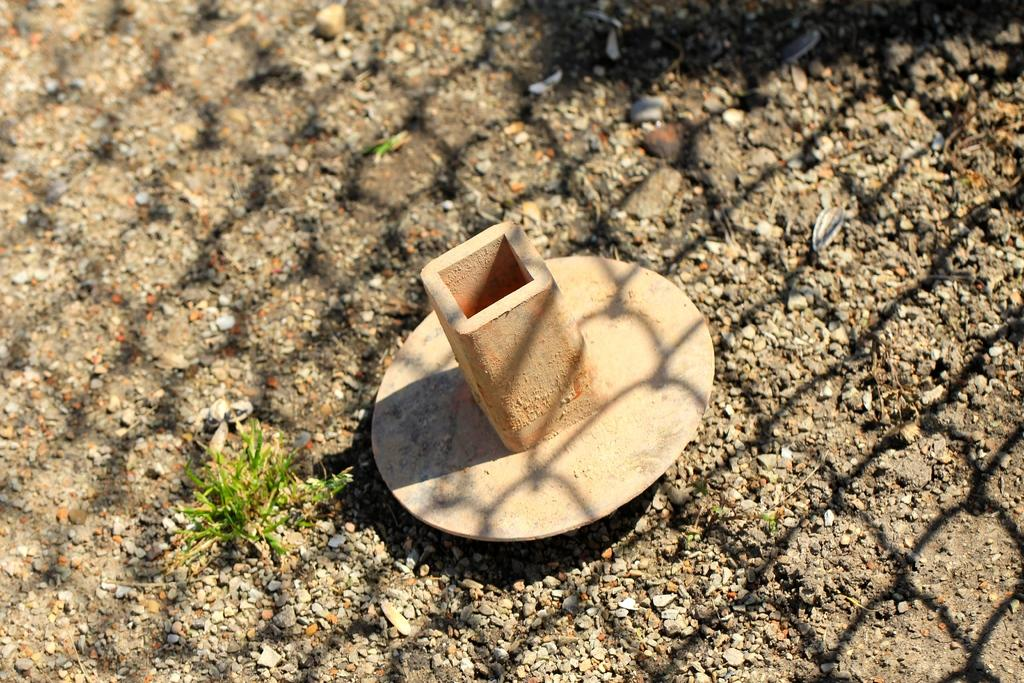What can be seen in the image? There is an object and a small plant in the image. Can you describe the object in the image? Unfortunately, the facts provided do not give enough information to describe the object in detail. What is on the ground in the background of the image? Stones are present on the ground in the background of the image. What type of cloth is draped over the pot in the image? There is no pot or cloth present in the image. 